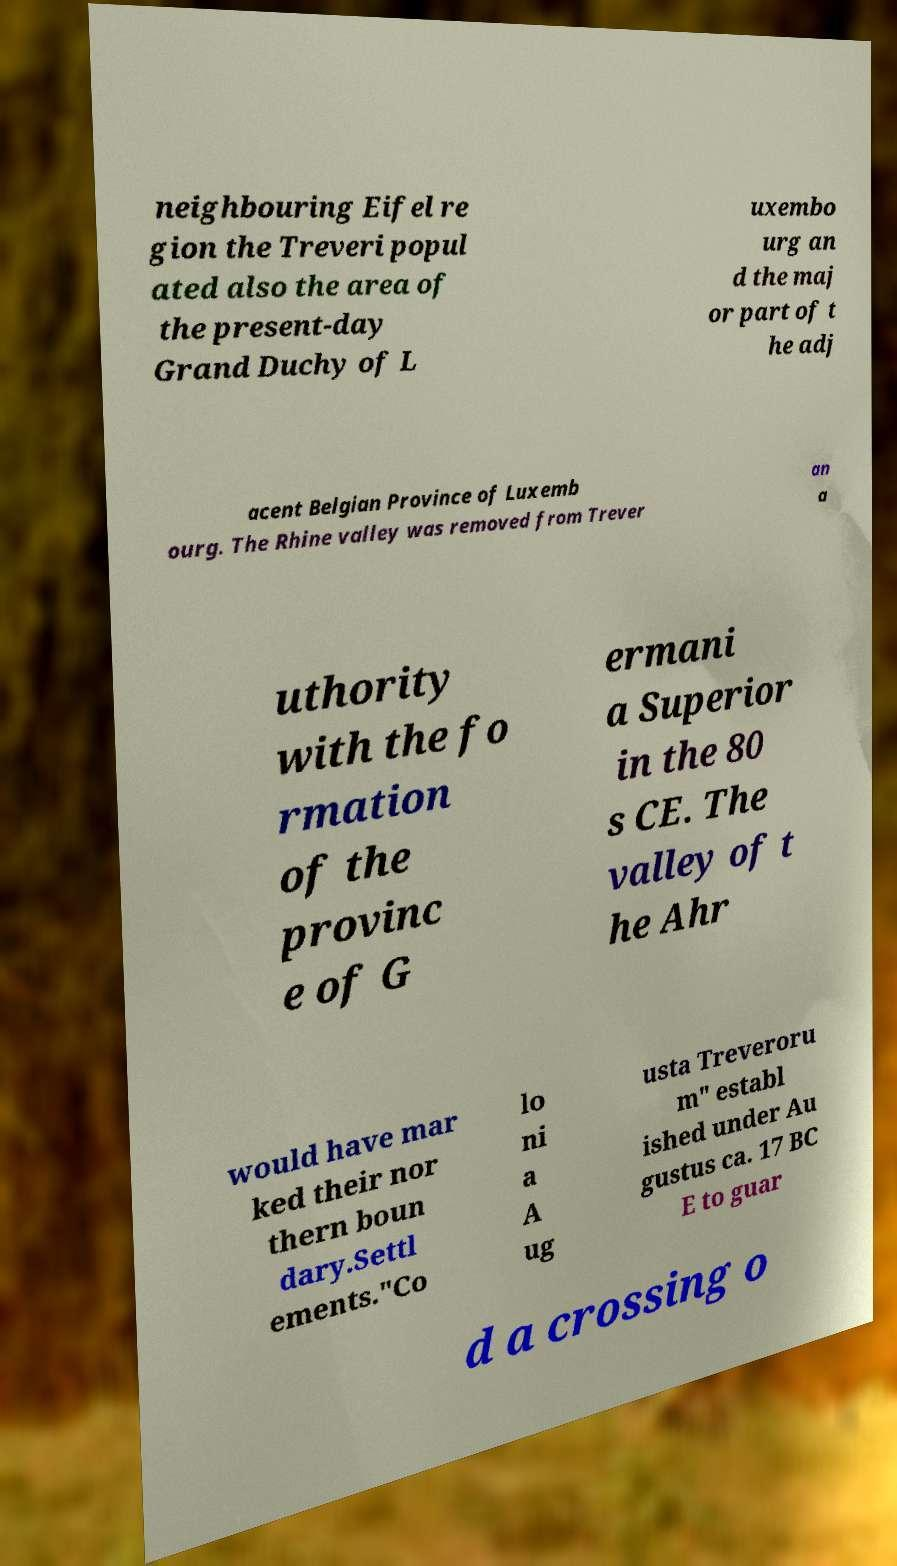What messages or text are displayed in this image? I need them in a readable, typed format. neighbouring Eifel re gion the Treveri popul ated also the area of the present-day Grand Duchy of L uxembo urg an d the maj or part of t he adj acent Belgian Province of Luxemb ourg. The Rhine valley was removed from Trever an a uthority with the fo rmation of the provinc e of G ermani a Superior in the 80 s CE. The valley of t he Ahr would have mar ked their nor thern boun dary.Settl ements."Co lo ni a A ug usta Treveroru m" establ ished under Au gustus ca. 17 BC E to guar d a crossing o 